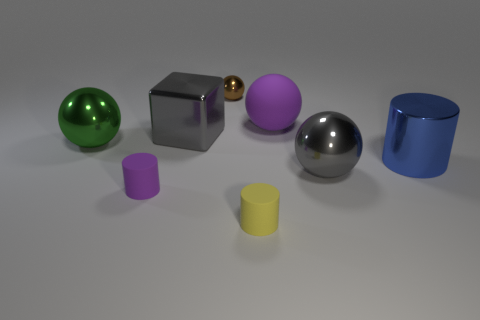Add 1 yellow objects. How many objects exist? 9 Subtract all cylinders. How many objects are left? 5 Add 8 gray matte objects. How many gray matte objects exist? 8 Subtract 1 purple cylinders. How many objects are left? 7 Subtract all small blue matte objects. Subtract all large purple matte objects. How many objects are left? 7 Add 3 tiny yellow matte cylinders. How many tiny yellow matte cylinders are left? 4 